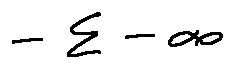Convert formula to latex. <formula><loc_0><loc_0><loc_500><loc_500>- \sum - \infty</formula> 